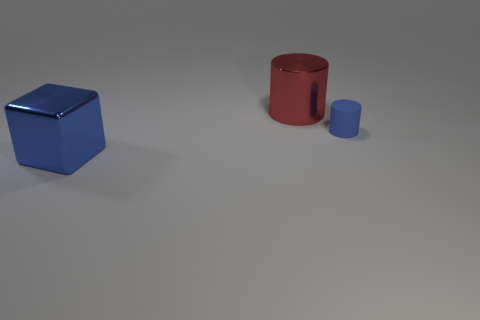Is the number of tiny purple matte things less than the number of objects?
Give a very brief answer. Yes. There is a thing to the left of the large metal object to the right of the big blue shiny object; what is its color?
Your response must be concise. Blue. What material is the big red thing that is the same shape as the small blue matte object?
Provide a succinct answer. Metal. What number of rubber things are large red cylinders or small gray things?
Make the answer very short. 0. Is the big cube in front of the large cylinder made of the same material as the big thing behind the metallic cube?
Your answer should be compact. Yes. Are there any blue metal things?
Make the answer very short. Yes. There is a large metal thing behind the blue cylinder; is it the same shape as the blue object in front of the tiny cylinder?
Ensure brevity in your answer.  No. Is there a large thing that has the same material as the blue cylinder?
Offer a terse response. No. Is the big thing to the left of the big red metallic cylinder made of the same material as the large red cylinder?
Give a very brief answer. Yes. Are there more rubber cylinders on the left side of the cube than blue metal cubes that are behind the big red cylinder?
Make the answer very short. No. 